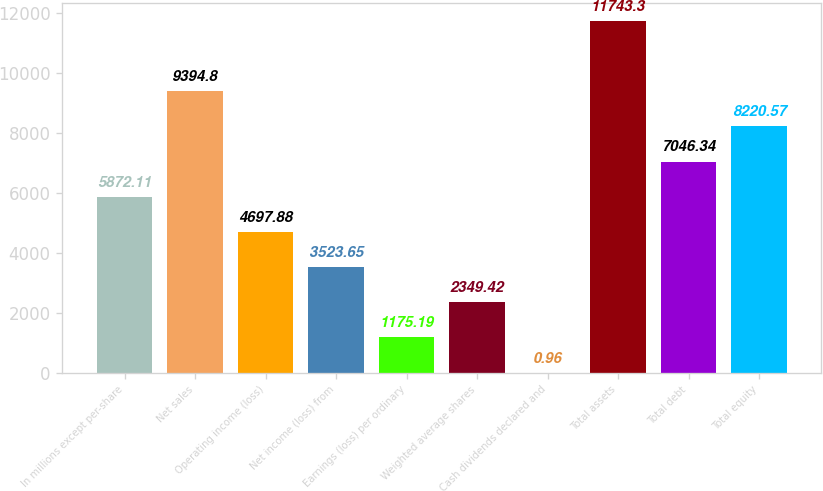Convert chart. <chart><loc_0><loc_0><loc_500><loc_500><bar_chart><fcel>In millions except per-share<fcel>Net sales<fcel>Operating income (loss)<fcel>Net income (loss) from<fcel>Earnings (loss) per ordinary<fcel>Weighted average shares<fcel>Cash dividends declared and<fcel>Total assets<fcel>Total debt<fcel>Total equity<nl><fcel>5872.11<fcel>9394.8<fcel>4697.88<fcel>3523.65<fcel>1175.19<fcel>2349.42<fcel>0.96<fcel>11743.3<fcel>7046.34<fcel>8220.57<nl></chart> 